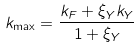Convert formula to latex. <formula><loc_0><loc_0><loc_500><loc_500>k _ { \max } = \frac { k _ { F } + \xi _ { Y } k _ { Y } } { 1 + \xi _ { Y } }</formula> 